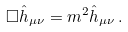<formula> <loc_0><loc_0><loc_500><loc_500>\Box \hat { h } _ { \mu \nu } = m ^ { 2 } \hat { h } _ { \mu \nu } \, .</formula> 